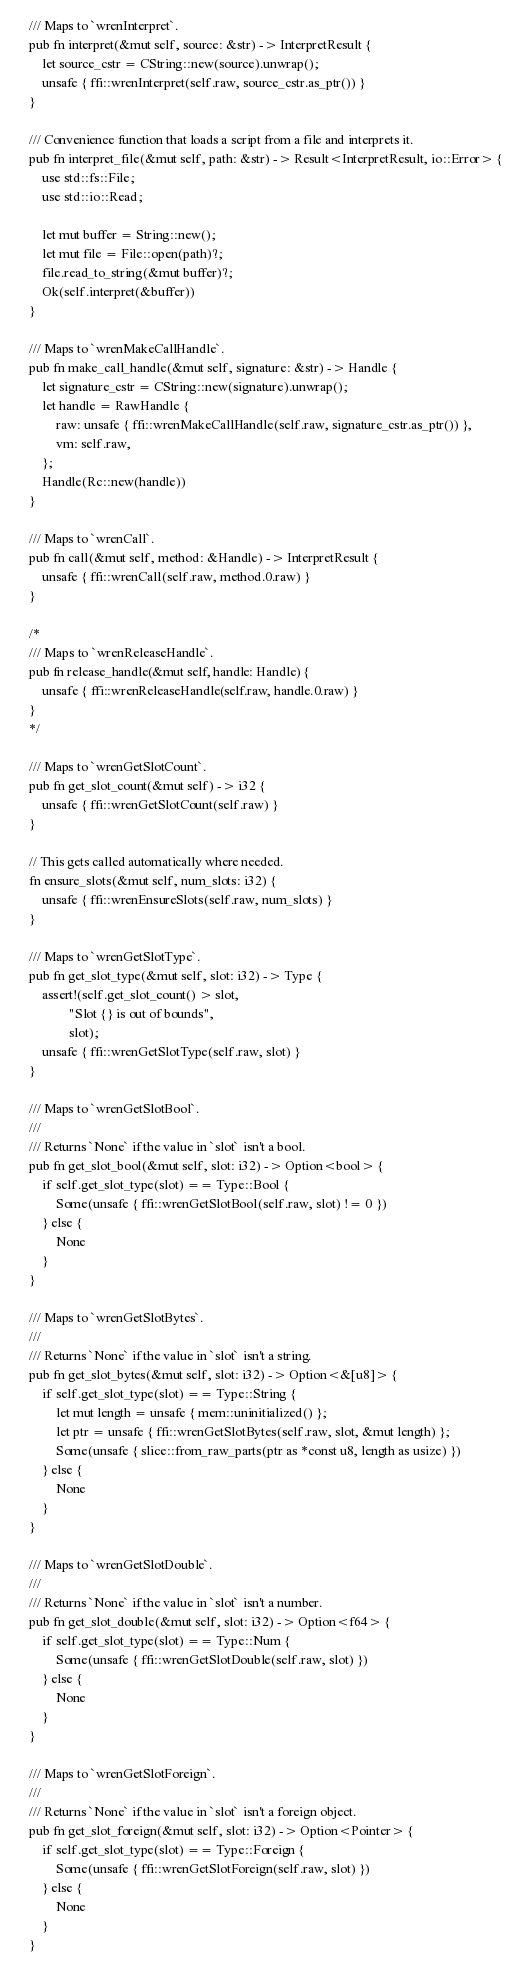Convert code to text. <code><loc_0><loc_0><loc_500><loc_500><_Rust_>    /// Maps to `wrenInterpret`.
    pub fn interpret(&mut self, source: &str) -> InterpretResult {
        let source_cstr = CString::new(source).unwrap();
        unsafe { ffi::wrenInterpret(self.raw, source_cstr.as_ptr()) }
    }

    /// Convenience function that loads a script from a file and interprets it.
    pub fn interpret_file(&mut self, path: &str) -> Result<InterpretResult, io::Error> {
        use std::fs::File;
        use std::io::Read;

        let mut buffer = String::new();
        let mut file = File::open(path)?;
        file.read_to_string(&mut buffer)?;
        Ok(self.interpret(&buffer))
    }

    /// Maps to `wrenMakeCallHandle`.
    pub fn make_call_handle(&mut self, signature: &str) -> Handle {
        let signature_cstr = CString::new(signature).unwrap();
        let handle = RawHandle {
            raw: unsafe { ffi::wrenMakeCallHandle(self.raw, signature_cstr.as_ptr()) },
            vm: self.raw,
        };
        Handle(Rc::new(handle))
    }

    /// Maps to `wrenCall`.
    pub fn call(&mut self, method: &Handle) -> InterpretResult {
        unsafe { ffi::wrenCall(self.raw, method.0.raw) }
    }

    /*
    /// Maps to `wrenReleaseHandle`.
    pub fn release_handle(&mut self, handle: Handle) {
        unsafe { ffi::wrenReleaseHandle(self.raw, handle.0.raw) }
    }
    */

    /// Maps to `wrenGetSlotCount`.
    pub fn get_slot_count(&mut self) -> i32 {
        unsafe { ffi::wrenGetSlotCount(self.raw) }
    }

    // This gets called automatically where needed.
    fn ensure_slots(&mut self, num_slots: i32) {
        unsafe { ffi::wrenEnsureSlots(self.raw, num_slots) }
    }

    /// Maps to `wrenGetSlotType`.
    pub fn get_slot_type(&mut self, slot: i32) -> Type {
        assert!(self.get_slot_count() > slot,
                "Slot {} is out of bounds",
                slot);
        unsafe { ffi::wrenGetSlotType(self.raw, slot) }
    }

    /// Maps to `wrenGetSlotBool`.
    ///
    /// Returns `None` if the value in `slot` isn't a bool.
    pub fn get_slot_bool(&mut self, slot: i32) -> Option<bool> {
        if self.get_slot_type(slot) == Type::Bool {
            Some(unsafe { ffi::wrenGetSlotBool(self.raw, slot) != 0 })
        } else {
            None
        }
    }

    /// Maps to `wrenGetSlotBytes`.
    ///
    /// Returns `None` if the value in `slot` isn't a string.
    pub fn get_slot_bytes(&mut self, slot: i32) -> Option<&[u8]> {
        if self.get_slot_type(slot) == Type::String {
            let mut length = unsafe { mem::uninitialized() };
            let ptr = unsafe { ffi::wrenGetSlotBytes(self.raw, slot, &mut length) };
            Some(unsafe { slice::from_raw_parts(ptr as *const u8, length as usize) })
        } else {
            None
        }
    }

    /// Maps to `wrenGetSlotDouble`.
    ///
    /// Returns `None` if the value in `slot` isn't a number.
    pub fn get_slot_double(&mut self, slot: i32) -> Option<f64> {
        if self.get_slot_type(slot) == Type::Num {
            Some(unsafe { ffi::wrenGetSlotDouble(self.raw, slot) })
        } else {
            None
        }
    }

    /// Maps to `wrenGetSlotForeign`.
    ///
    /// Returns `None` if the value in `slot` isn't a foreign object.
    pub fn get_slot_foreign(&mut self, slot: i32) -> Option<Pointer> {
        if self.get_slot_type(slot) == Type::Foreign {
            Some(unsafe { ffi::wrenGetSlotForeign(self.raw, slot) })
        } else {
            None
        }
    }
</code> 